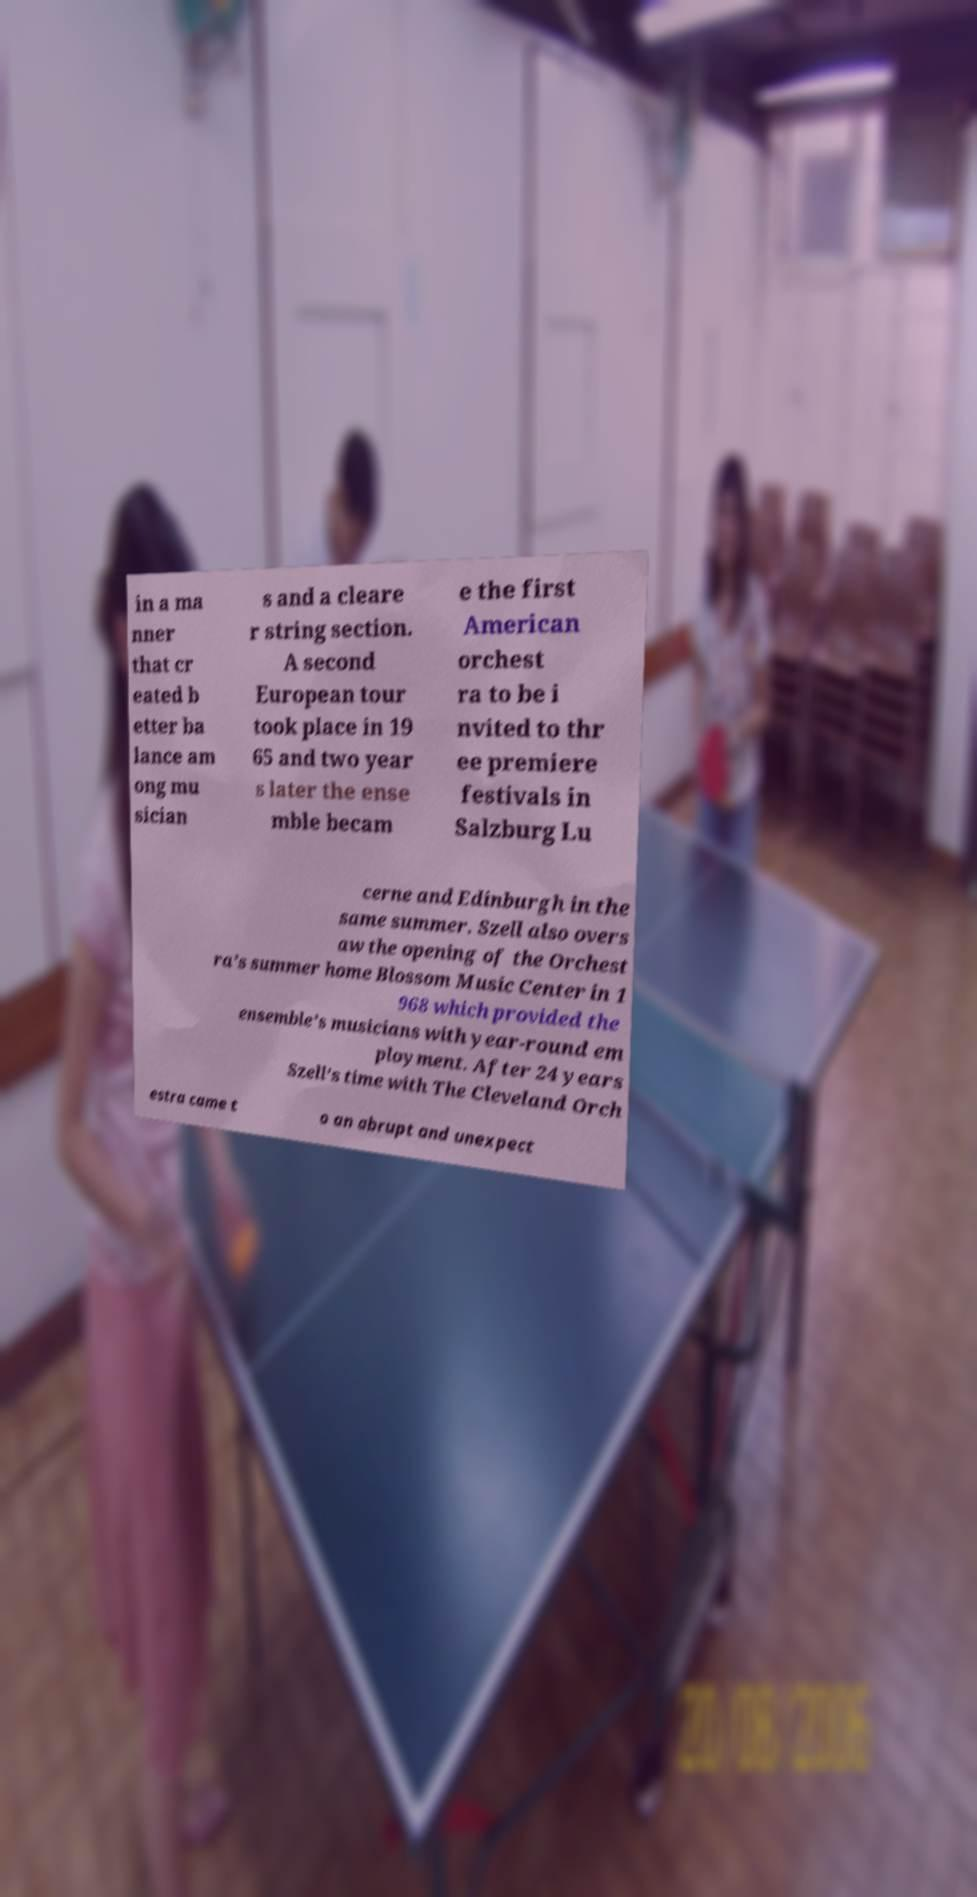Could you assist in decoding the text presented in this image and type it out clearly? in a ma nner that cr eated b etter ba lance am ong mu sician s and a cleare r string section. A second European tour took place in 19 65 and two year s later the ense mble becam e the first American orchest ra to be i nvited to thr ee premiere festivals in Salzburg Lu cerne and Edinburgh in the same summer. Szell also overs aw the opening of the Orchest ra’s summer home Blossom Music Center in 1 968 which provided the ensemble’s musicians with year-round em ployment. After 24 years Szell’s time with The Cleveland Orch estra came t o an abrupt and unexpect 